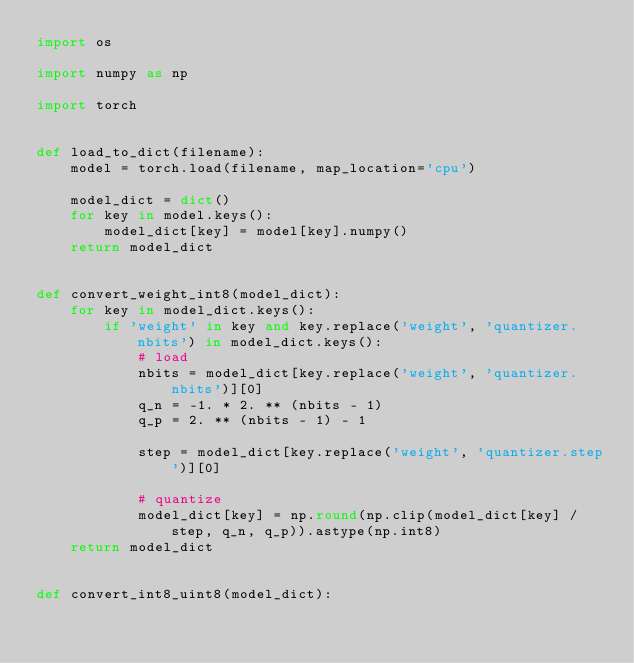<code> <loc_0><loc_0><loc_500><loc_500><_Python_>import os

import numpy as np

import torch


def load_to_dict(filename):
    model = torch.load(filename, map_location='cpu')

    model_dict = dict()
    for key in model.keys():
        model_dict[key] = model[key].numpy()
    return model_dict


def convert_weight_int8(model_dict):
    for key in model_dict.keys():
        if 'weight' in key and key.replace('weight', 'quantizer.nbits') in model_dict.keys():
            # load
            nbits = model_dict[key.replace('weight', 'quantizer.nbits')][0]
            q_n = -1. * 2. ** (nbits - 1)
            q_p = 2. ** (nbits - 1) - 1

            step = model_dict[key.replace('weight', 'quantizer.step')][0]

            # quantize
            model_dict[key] = np.round(np.clip(model_dict[key] / step, q_n, q_p)).astype(np.int8)
    return model_dict


def convert_int8_uint8(model_dict):</code> 